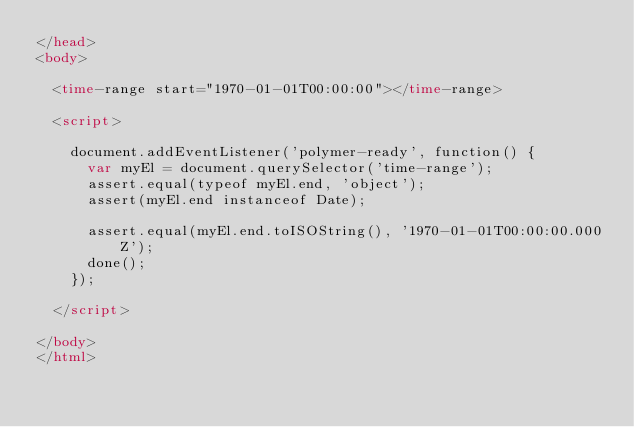Convert code to text. <code><loc_0><loc_0><loc_500><loc_500><_HTML_></head>
<body>

  <time-range start="1970-01-01T00:00:00"></time-range>

  <script>

    document.addEventListener('polymer-ready', function() {
      var myEl = document.querySelector('time-range');
      assert.equal(typeof myEl.end, 'object');
      assert(myEl.end instanceof Date);

      assert.equal(myEl.end.toISOString(), '1970-01-01T00:00:00.000Z');
      done();
    });

  </script>

</body>
</html>
</code> 